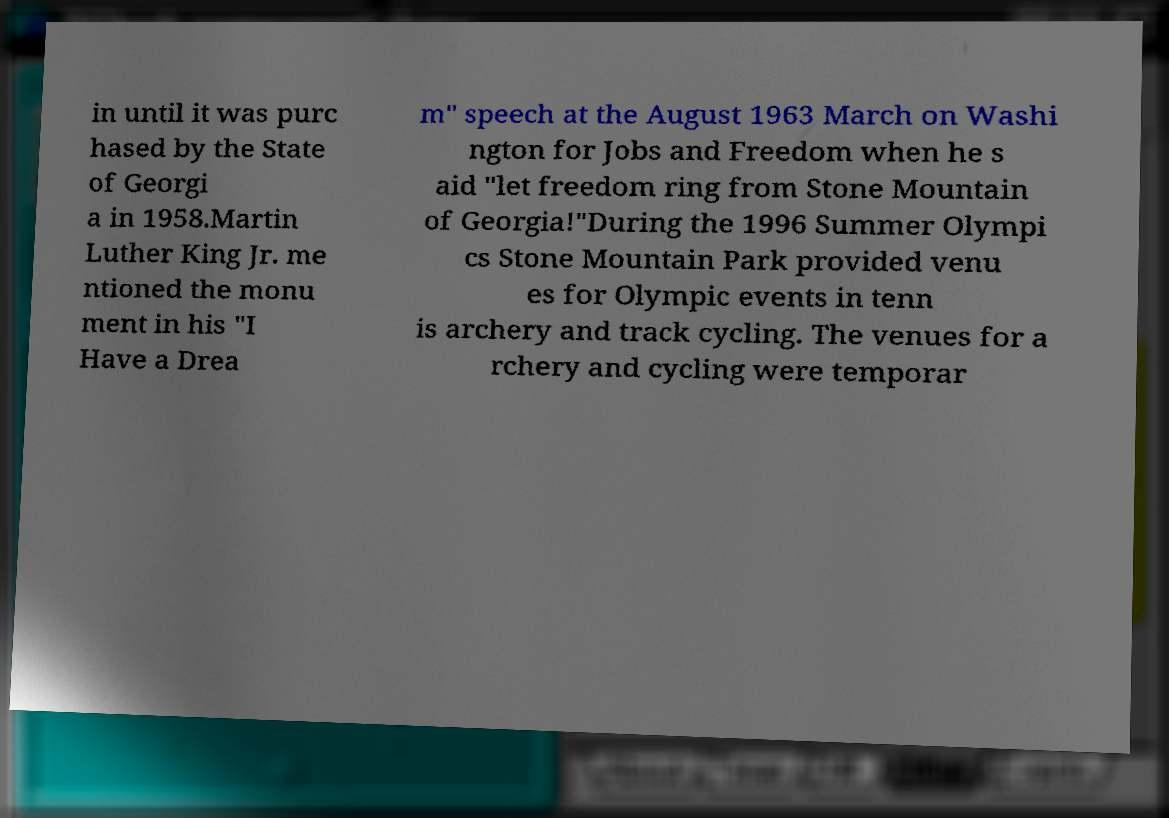I need the written content from this picture converted into text. Can you do that? in until it was purc hased by the State of Georgi a in 1958.Martin Luther King Jr. me ntioned the monu ment in his "I Have a Drea m" speech at the August 1963 March on Washi ngton for Jobs and Freedom when he s aid "let freedom ring from Stone Mountain of Georgia!"During the 1996 Summer Olympi cs Stone Mountain Park provided venu es for Olympic events in tenn is archery and track cycling. The venues for a rchery and cycling were temporar 